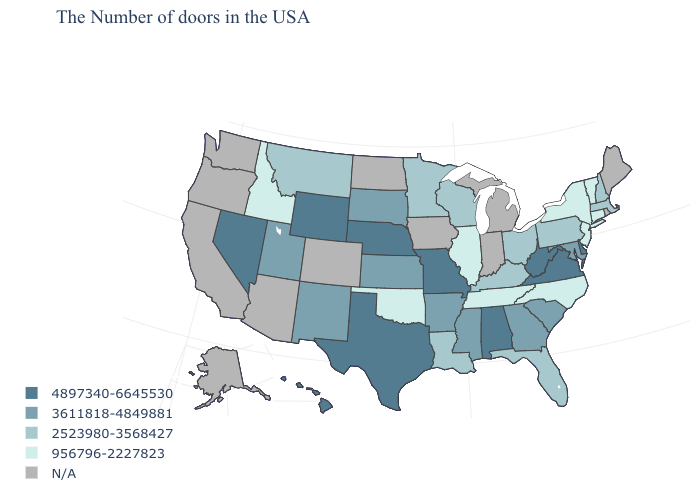Does Wyoming have the highest value in the West?
Answer briefly. Yes. Name the states that have a value in the range 2523980-3568427?
Give a very brief answer. Massachusetts, New Hampshire, Pennsylvania, Ohio, Florida, Kentucky, Wisconsin, Louisiana, Minnesota, Montana. Which states hav the highest value in the MidWest?
Concise answer only. Missouri, Nebraska. Does Nebraska have the highest value in the USA?
Answer briefly. Yes. Among the states that border Mississippi , does Alabama have the highest value?
Short answer required. Yes. Among the states that border Delaware , which have the lowest value?
Quick response, please. New Jersey. Among the states that border South Dakota , which have the highest value?
Concise answer only. Nebraska, Wyoming. Which states have the highest value in the USA?
Keep it brief. Delaware, Virginia, West Virginia, Alabama, Missouri, Nebraska, Texas, Wyoming, Nevada, Hawaii. Is the legend a continuous bar?
Concise answer only. No. Is the legend a continuous bar?
Give a very brief answer. No. Name the states that have a value in the range 4897340-6645530?
Write a very short answer. Delaware, Virginia, West Virginia, Alabama, Missouri, Nebraska, Texas, Wyoming, Nevada, Hawaii. What is the value of New York?
Concise answer only. 956796-2227823. Name the states that have a value in the range 956796-2227823?
Short answer required. Vermont, Connecticut, New York, New Jersey, North Carolina, Tennessee, Illinois, Oklahoma, Idaho. Does Massachusetts have the highest value in the Northeast?
Answer briefly. Yes. 